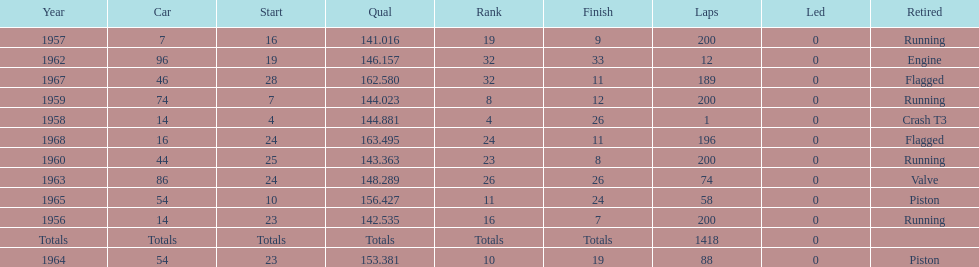How long did bob veith have the number 54 car at the indy 500? 2 years. 